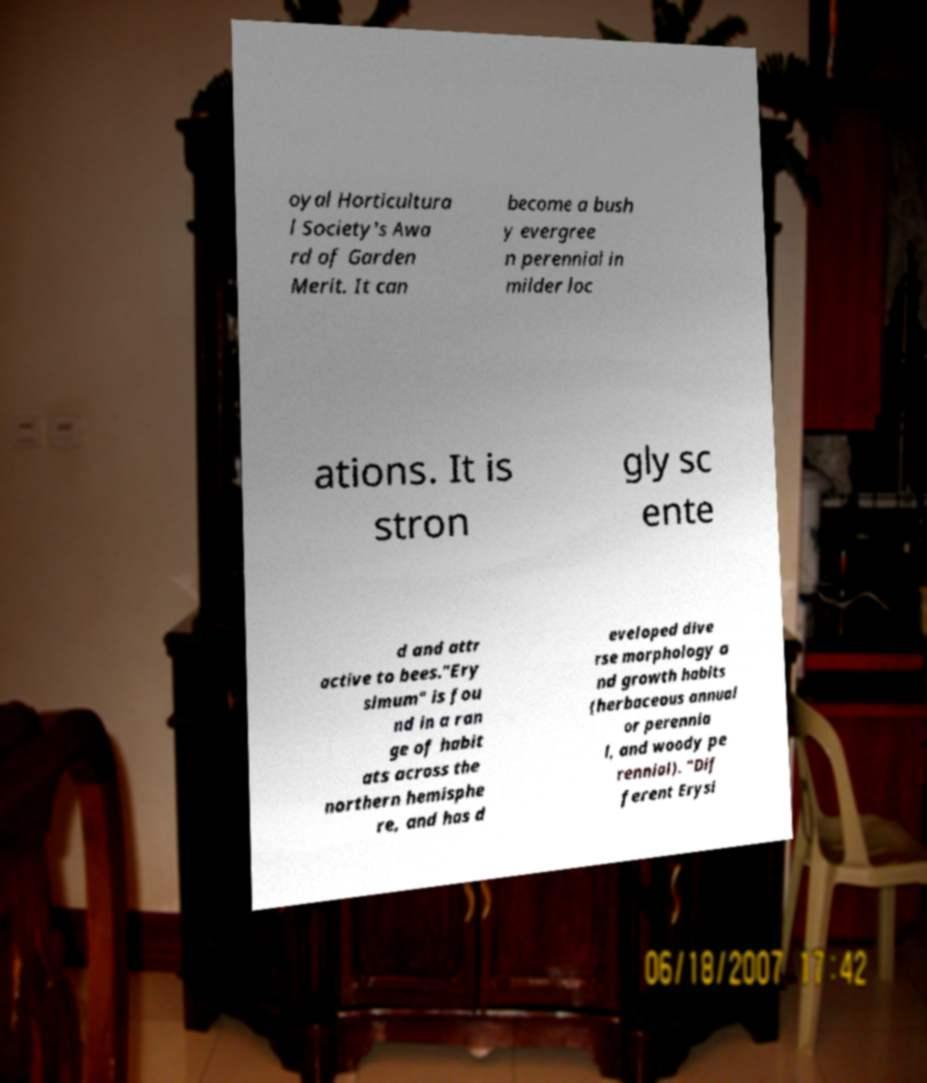For documentation purposes, I need the text within this image transcribed. Could you provide that? oyal Horticultura l Society's Awa rd of Garden Merit. It can become a bush y evergree n perennial in milder loc ations. It is stron gly sc ente d and attr active to bees."Ery simum" is fou nd in a ran ge of habit ats across the northern hemisphe re, and has d eveloped dive rse morphology a nd growth habits (herbaceous annual or perennia l, and woody pe rennial). "Dif ferent Erysi 